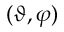Convert formula to latex. <formula><loc_0><loc_0><loc_500><loc_500>( \vartheta , \varphi )</formula> 